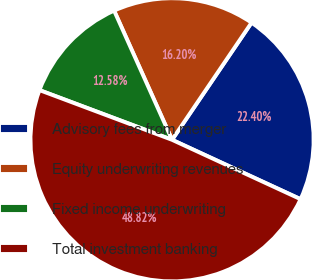<chart> <loc_0><loc_0><loc_500><loc_500><pie_chart><fcel>Advisory fees from merger<fcel>Equity underwriting revenues<fcel>Fixed income underwriting<fcel>Total investment banking<nl><fcel>22.4%<fcel>16.2%<fcel>12.58%<fcel>48.82%<nl></chart> 